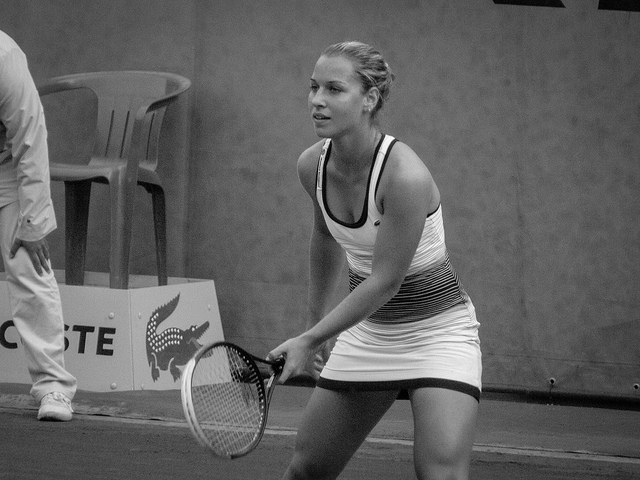<image>What letter is on the racket? I am unsure what letter is on the racket. It could possibly be 'x', 'w', 's', 'z', or no letter at all. What letter is on the racket? There is no letter on the racket in the image. 